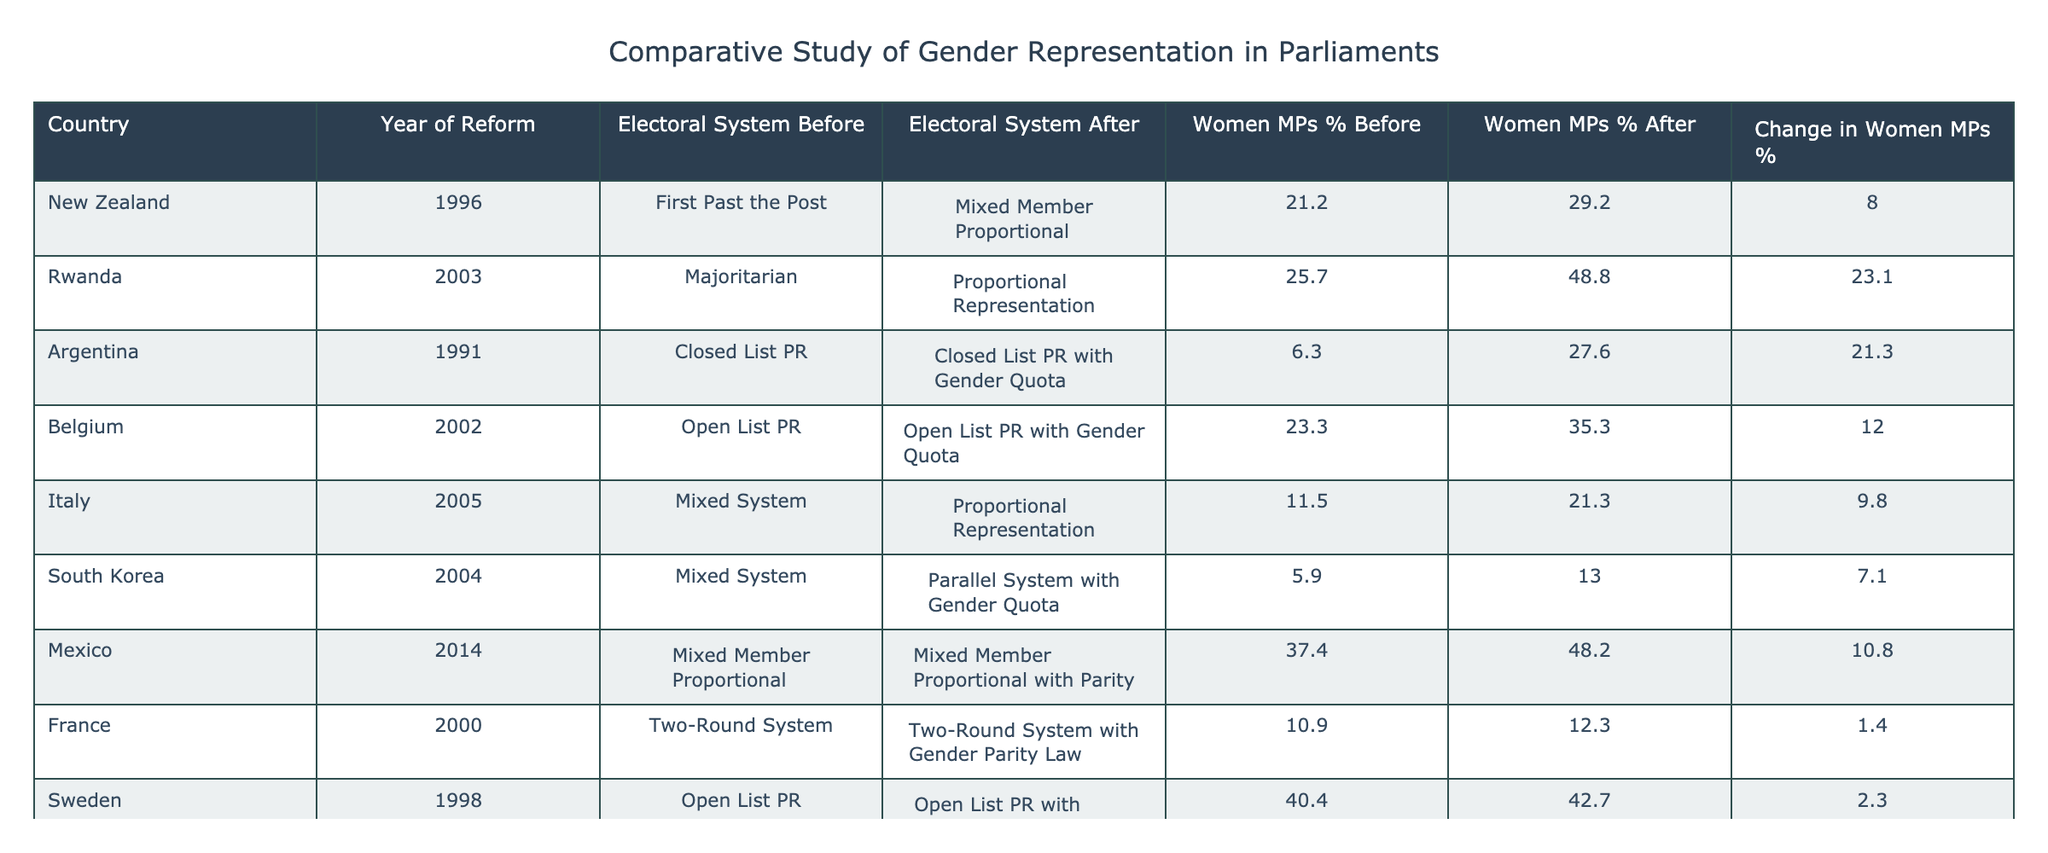What was the percentage of women MPs in Rwanda before the electoral reform in 2003? According to the table, Rwanda had 25.7% of women MPs before the electoral reform in 2003.
Answer: 25.7% Which country had the highest increase in the percentage of women MPs after electoral reform? By comparing the "Change in Women MPs %" column, Bolivia had the highest increase of 36.2% after electoral reform.
Answer: Bolivia Did Argentina’s electoral reform in 1991 involve a change in the electoral system? The table shows that Argentina's electoral system remained as Closed List PR with the addition of a gender quota, indicating that there was a change due to the introduction of the gender quota.
Answer: Yes What is the average percentage of women MPs before electoral reforms across all countries in the table? The average percentage is calculated as follows: (21.2 + 25.7 + 6.3 + 23.3 + 11.5 + 5.9 + 37.4 + 10.9 + 40.4 + 16.9) / 10 = 19.06%.
Answer: 19.06% Which country showed the least change in the percentage of women MPs after electoral reform? From the table data, France showed the least change with an increase of only 1.4% after the electoral reform.
Answer: France How many countries had more than a 20% increase in women MPs after reform? By reviewing the "Change in Women MPs %" column, Rwanda, Argentina, Bolivia all had increases greater than 20%. Thus, there are 3 countries with such an increase.
Answer: 3 What percentage of women MPs did New Zealand achieve post-reform in 1996? The table indicates that after the electoral reform in New Zealand in 1996, the percentage of women MPs rose to 29.2%.
Answer: 29.2% Is the percentage of women MPs greater in Sweden after reform compared to Italy after their respective reforms? Sweden's percentage after reform is 42.7%, while Italy's is 21.3%. Since 42.7% is greater than 21.3%, the statement is true.
Answer: Yes 